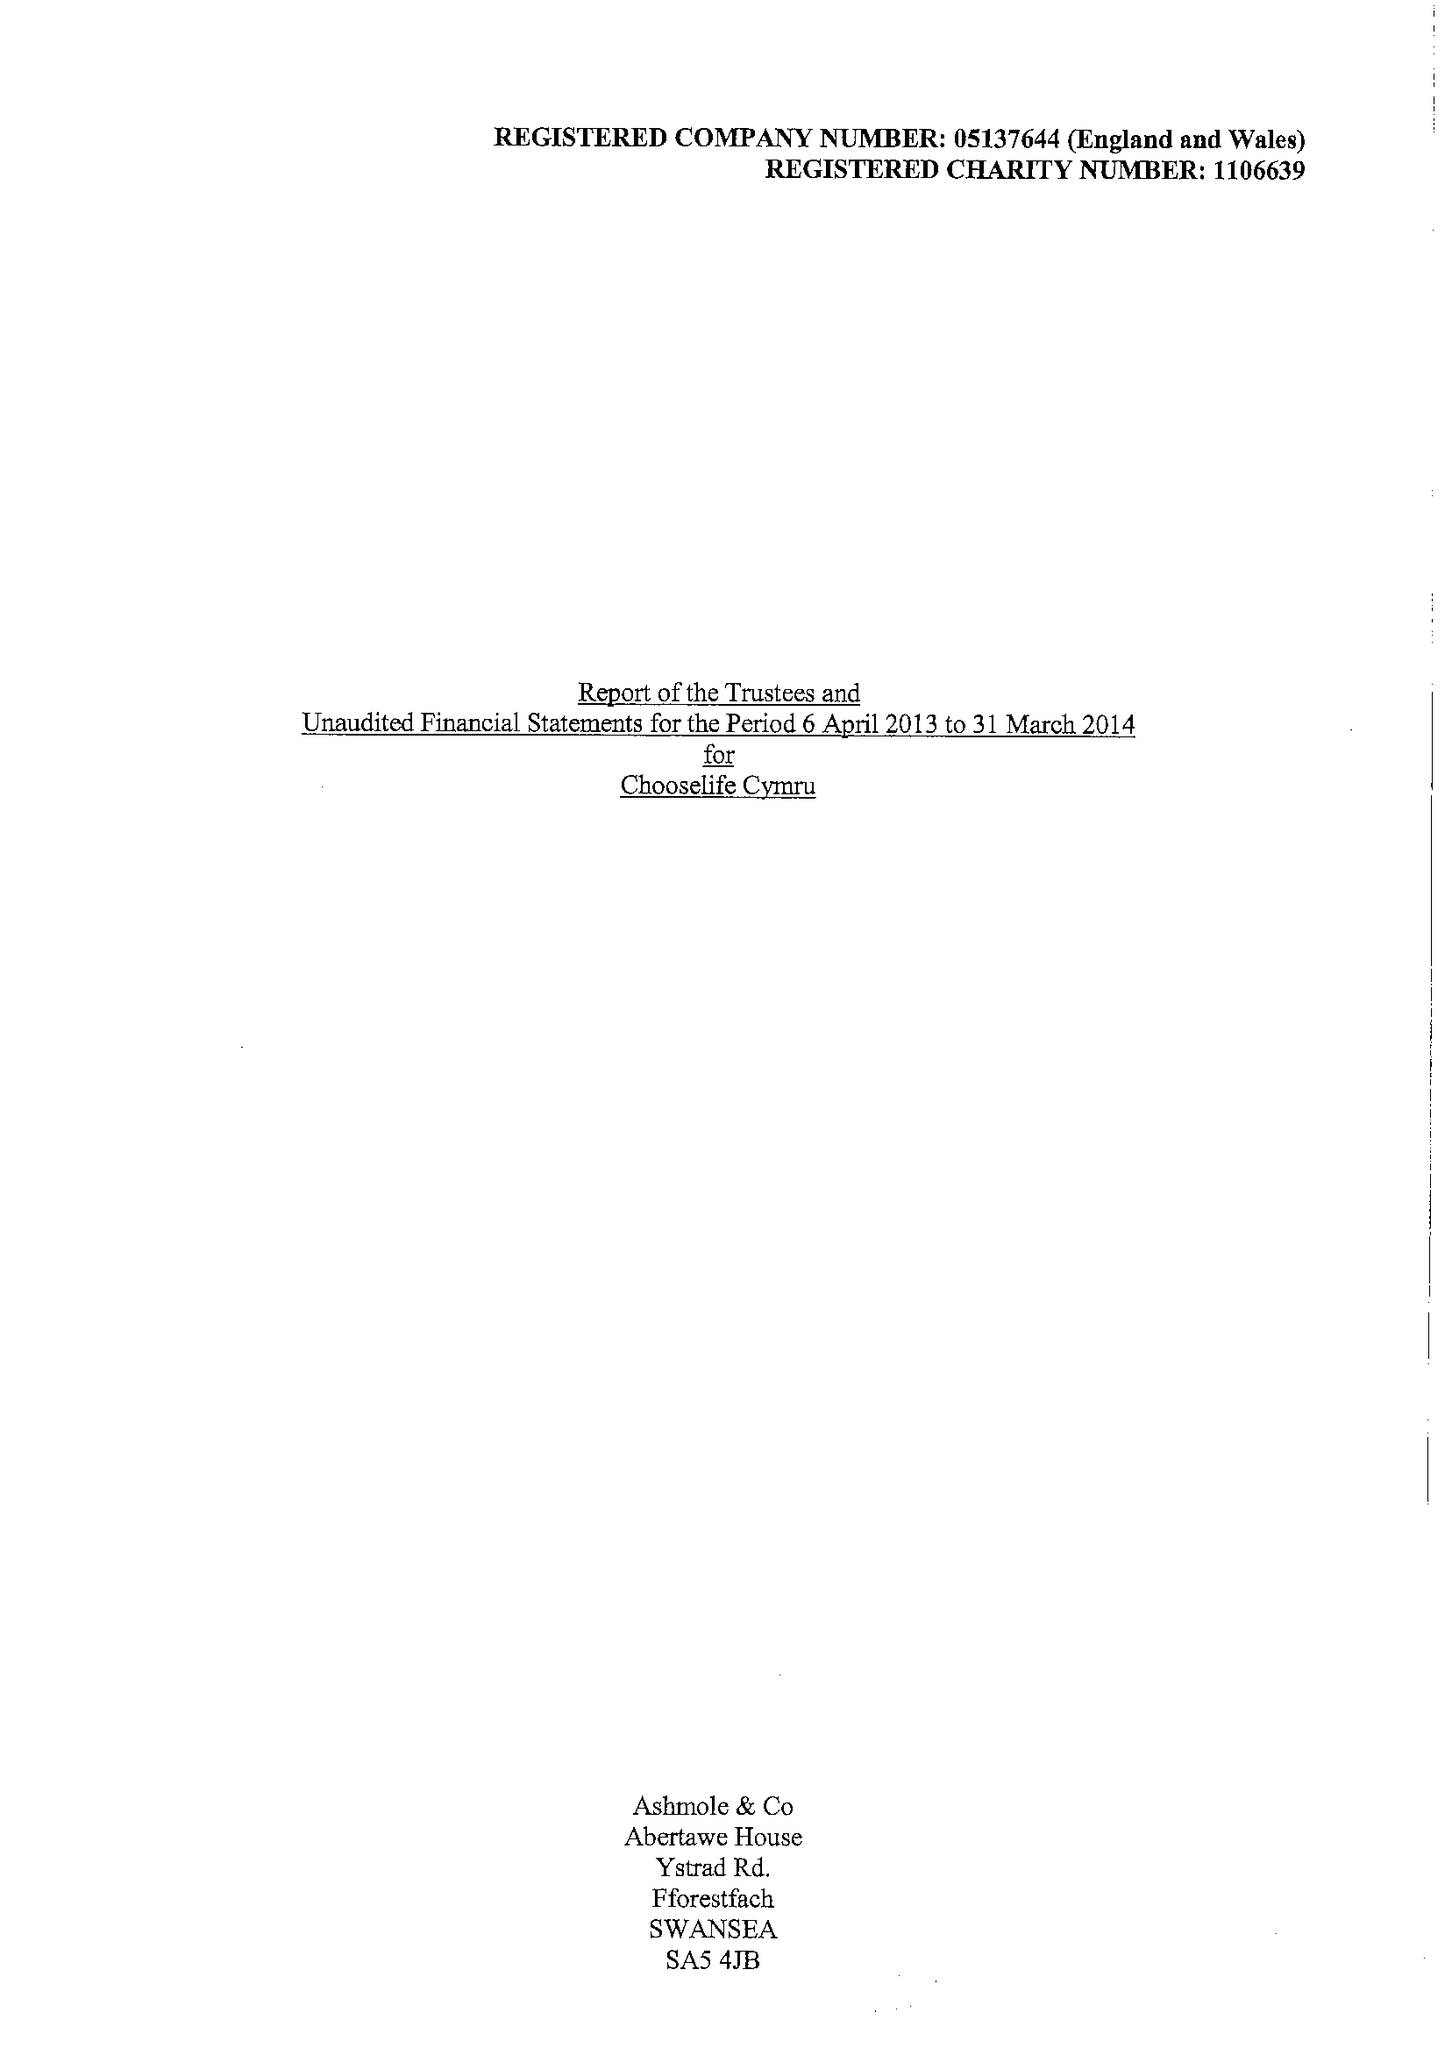What is the value for the address__street_line?
Answer the question using a single word or phrase. None 